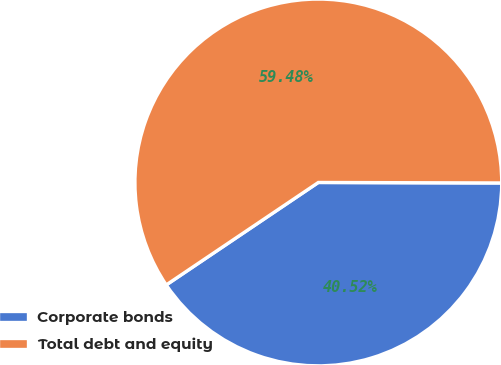<chart> <loc_0><loc_0><loc_500><loc_500><pie_chart><fcel>Corporate bonds<fcel>Total debt and equity<nl><fcel>40.52%<fcel>59.48%<nl></chart> 